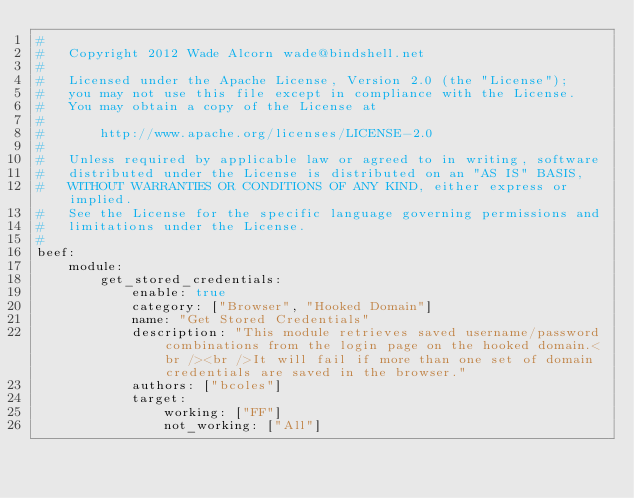Convert code to text. <code><loc_0><loc_0><loc_500><loc_500><_YAML_>#
#   Copyright 2012 Wade Alcorn wade@bindshell.net
#
#   Licensed under the Apache License, Version 2.0 (the "License");
#   you may not use this file except in compliance with the License.
#   You may obtain a copy of the License at
#
#       http://www.apache.org/licenses/LICENSE-2.0
#
#   Unless required by applicable law or agreed to in writing, software
#   distributed under the License is distributed on an "AS IS" BASIS,
#   WITHOUT WARRANTIES OR CONDITIONS OF ANY KIND, either express or implied.
#   See the License for the specific language governing permissions and
#   limitations under the License.
#
beef:
    module:
        get_stored_credentials:
            enable: true
            category: ["Browser", "Hooked Domain"]
            name: "Get Stored Credentials"
            description: "This module retrieves saved username/password combinations from the login page on the hooked domain.<br /><br />It will fail if more than one set of domain credentials are saved in the browser."
            authors: ["bcoles"]
            target:
                working: ["FF"]
                not_working: ["All"]

</code> 